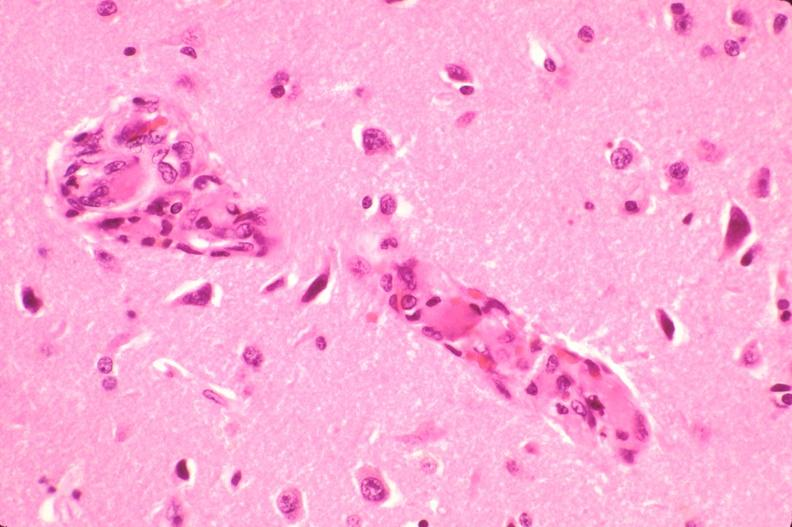what does this image show?
Answer the question using a single word or phrase. Brain 